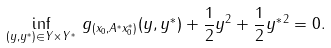<formula> <loc_0><loc_0><loc_500><loc_500>\inf _ { ( y , y ^ { * } ) \in Y \times Y ^ { * } } \, g _ { ( x _ { 0 } , A ^ { * } x _ { 0 } ^ { * } ) } ( y , y ^ { * } ) + \frac { 1 } { 2 } \| y \| ^ { 2 } + \frac { 1 } { 2 } \| y ^ { * } \| ^ { 2 } = 0 .</formula> 